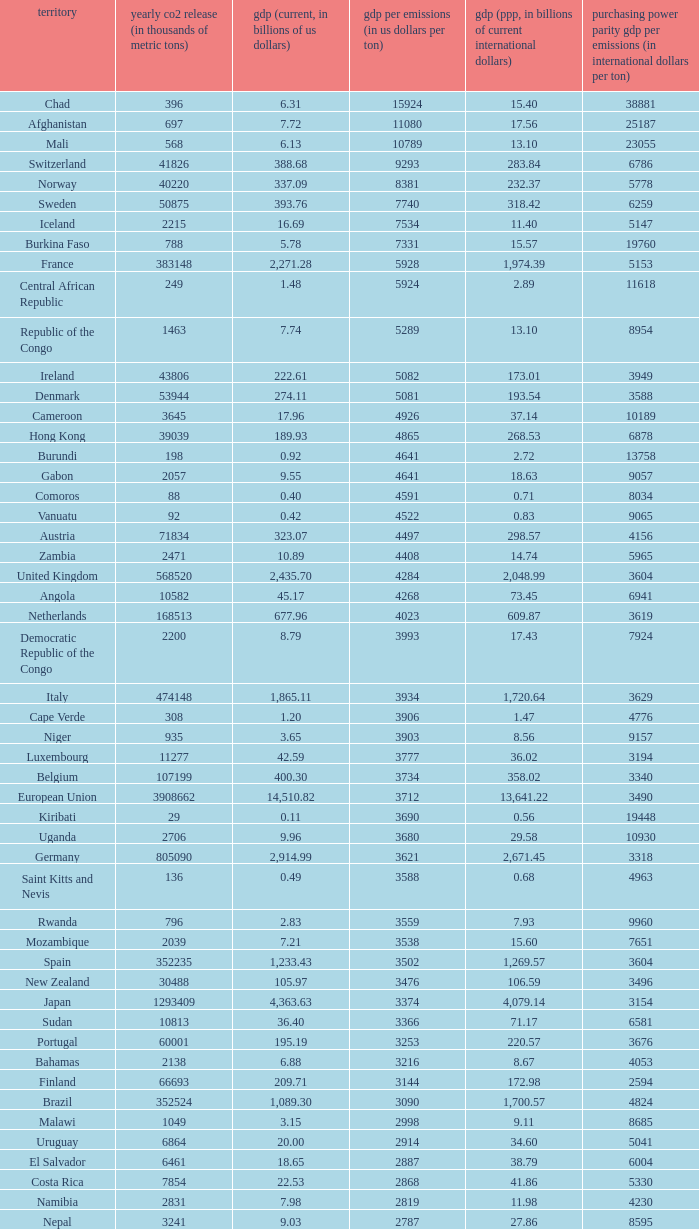When the gdp per emissions (in us dollars per ton) is 3903, what is the maximum annual co2 emissions (in thousands of metric tons)? 935.0. 